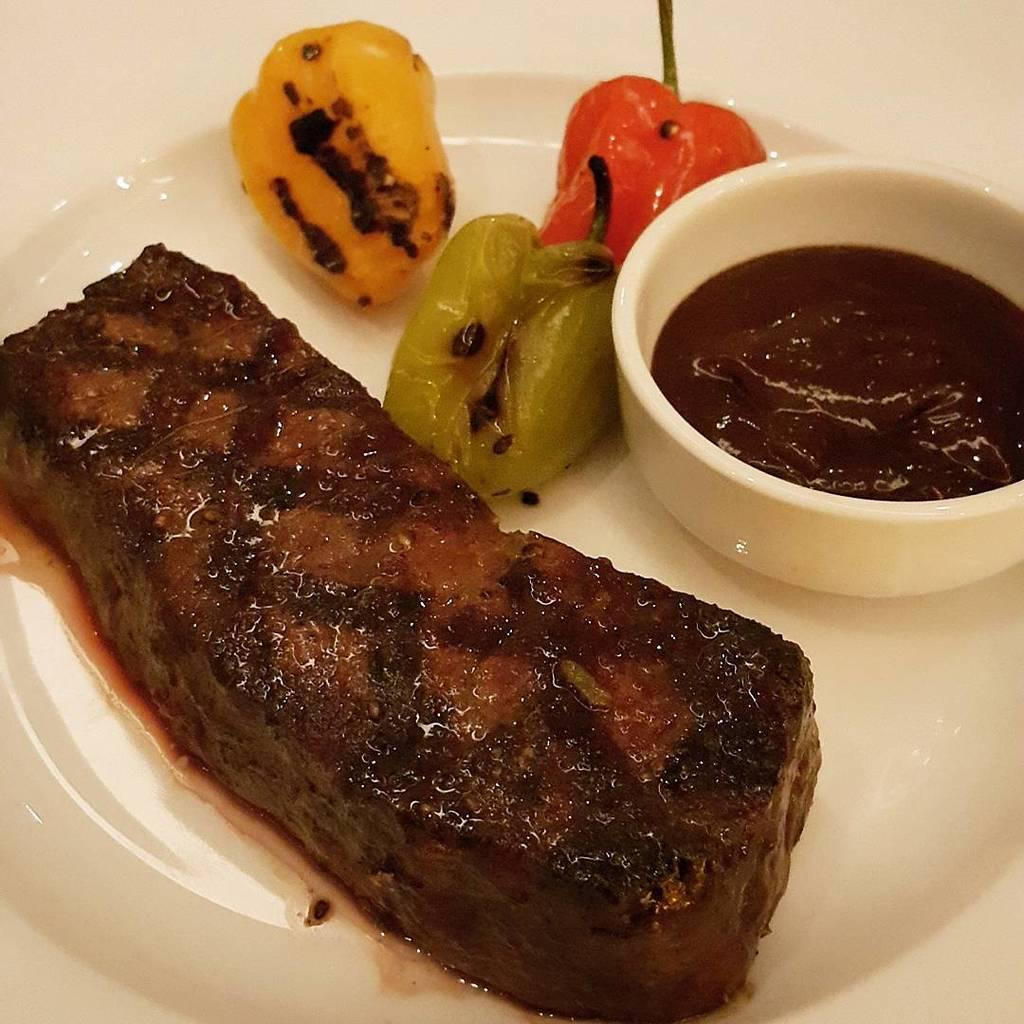What is present on the plate in the image? There are food items on a plate in the image. What can be seen besides the plate in the image? There is a cup visible in the image. What is the color of the plate? The plate is white in color. What type of riddle can be solved using the grains on the plate in the image? There is no riddle or grain present in the image; it features a cup and a plate with food items. 